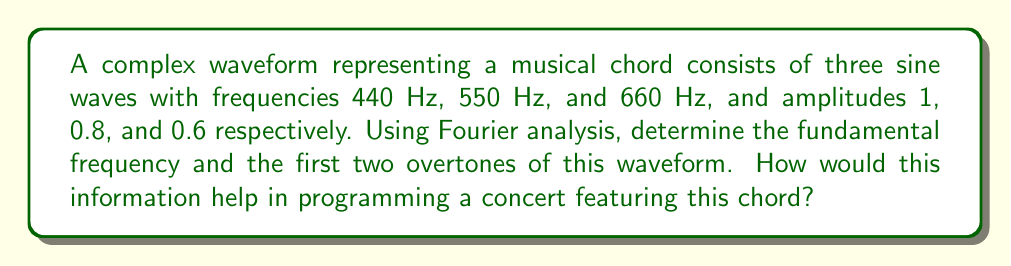Provide a solution to this math problem. Let's approach this step-by-step using Fourier analysis:

1) The complex waveform $f(t)$ can be represented as:

   $$f(t) = 1 \sin(2\pi \cdot 440t) + 0.8 \sin(2\pi \cdot 550t) + 0.6 \sin(2\pi \cdot 660t)$$

2) In Fourier analysis, we decompose a periodic signal into its constituent frequencies. Here, we already have the constituent frequencies, but we need to identify the fundamental and overtones.

3) The fundamental frequency is the greatest common divisor (GCD) of all frequencies present:

   $$GCD(440, 550, 660) = 110 \text{ Hz}$$

4) This means our waveform has a fundamental frequency of 110 Hz.

5) The overtones are integer multiples of the fundamental frequency:
   - First overtone: $2 \cdot 110 = 220 \text{ Hz}$
   - Second overtone: $3 \cdot 110 = 330 \text{ Hz}$

6) We can rewrite our frequencies in terms of the fundamental:
   - 440 Hz = 4th harmonic (4 * 110 Hz)
   - 550 Hz = 5th harmonic (5 * 110 Hz)
   - 660 Hz = 6th harmonic (6 * 110 Hz)

7) For programming decisions, this analysis reveals:
   - The chord is built on A2 (110 Hz)
   - It contains the 4th, 5th, and 6th harmonics
   - The relative strengths of these harmonics are 1 : 0.8 : 0.6

This information can guide instrument selection, arrangement decisions, and help in creating complementary harmonies or contrasting sections in the concert program.
Answer: Fundamental: 110 Hz; First overtone: 220 Hz; Second overtone: 330 Hz 